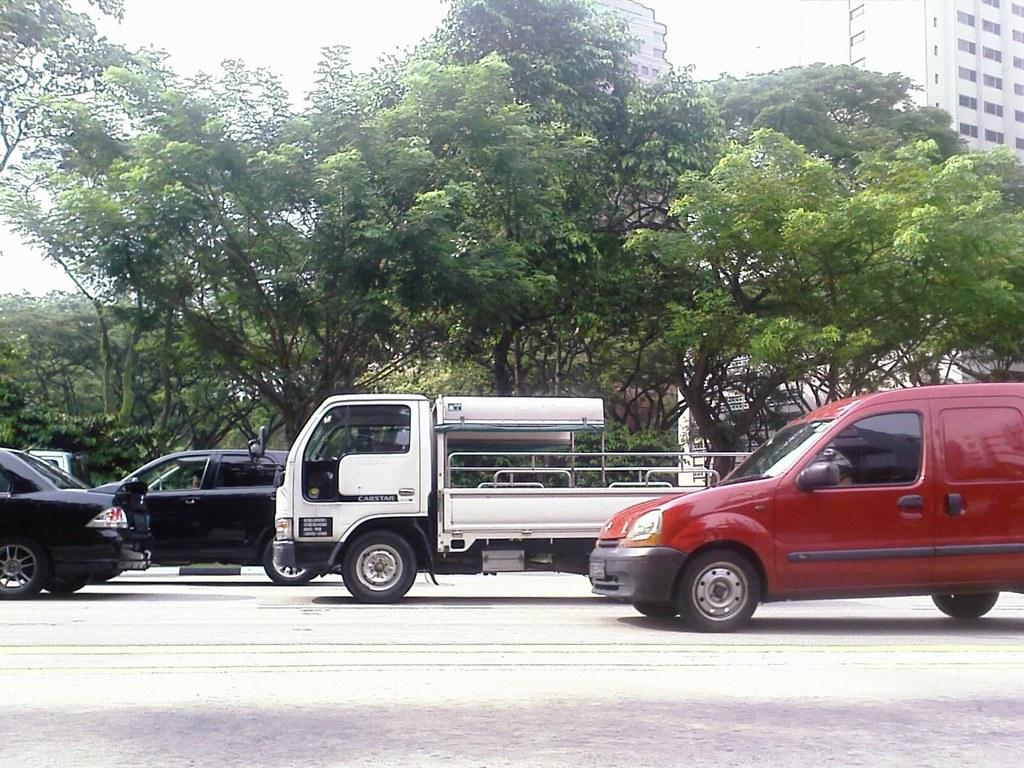What type of structures can be seen in the background of the image? There are buildings in the background of the image. What is the weather like in the image? It appears to be a sunny day in the image. What type of vegetation is visible in the image? There are trees visible in the image. What type of transportation can be seen on the road in the image? There are vehicles on the road in the image. Is there a bomb hanging from the tree in the image? No, there is no bomb present in the image. What type of leather material can be seen on the vehicles in the image? There is no leather material visible on the vehicles in the image. 